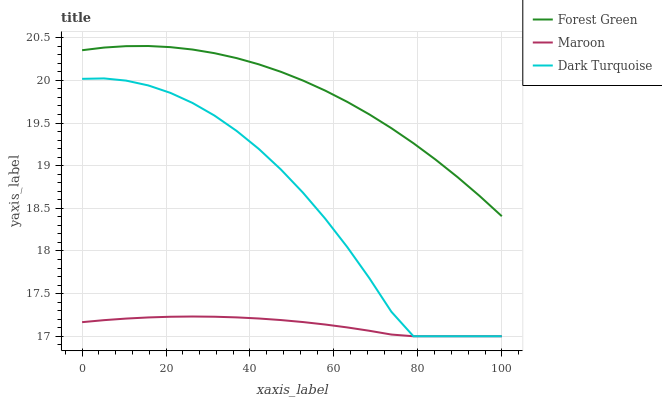Does Maroon have the minimum area under the curve?
Answer yes or no. Yes. Does Forest Green have the maximum area under the curve?
Answer yes or no. Yes. Does Forest Green have the minimum area under the curve?
Answer yes or no. No. Does Maroon have the maximum area under the curve?
Answer yes or no. No. Is Maroon the smoothest?
Answer yes or no. Yes. Is Dark Turquoise the roughest?
Answer yes or no. Yes. Is Forest Green the smoothest?
Answer yes or no. No. Is Forest Green the roughest?
Answer yes or no. No. Does Dark Turquoise have the lowest value?
Answer yes or no. Yes. Does Forest Green have the lowest value?
Answer yes or no. No. Does Forest Green have the highest value?
Answer yes or no. Yes. Does Maroon have the highest value?
Answer yes or no. No. Is Dark Turquoise less than Forest Green?
Answer yes or no. Yes. Is Forest Green greater than Maroon?
Answer yes or no. Yes. Does Maroon intersect Dark Turquoise?
Answer yes or no. Yes. Is Maroon less than Dark Turquoise?
Answer yes or no. No. Is Maroon greater than Dark Turquoise?
Answer yes or no. No. Does Dark Turquoise intersect Forest Green?
Answer yes or no. No. 